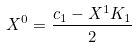Convert formula to latex. <formula><loc_0><loc_0><loc_500><loc_500>X ^ { 0 } = \frac { c _ { 1 } - X ^ { 1 } K _ { 1 } } 2</formula> 